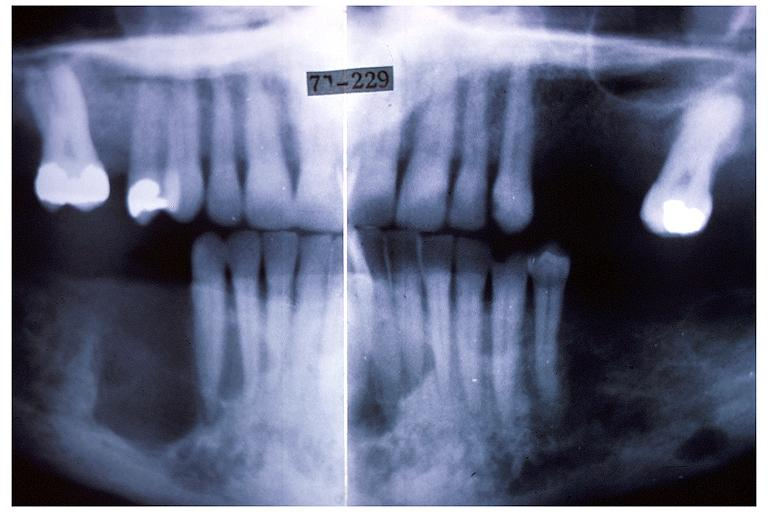where is this?
Answer the question using a single word or phrase. Oral 